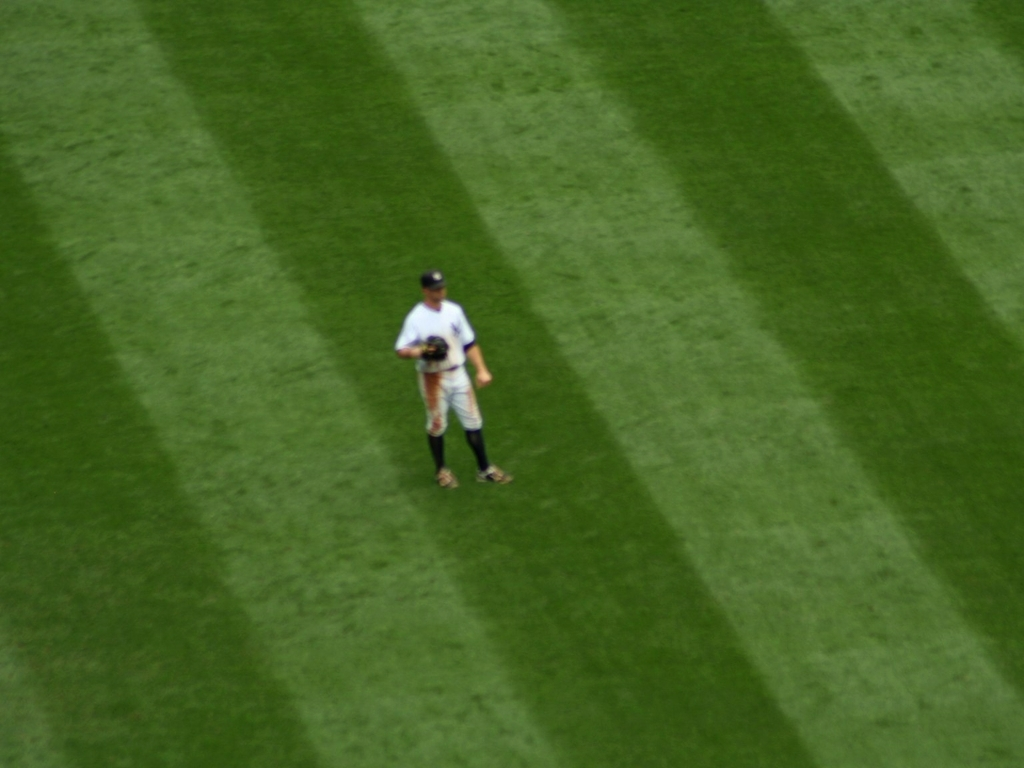Could the time of day influence the appearance of this image, and if so, how? Absolutely, the time of day can significantly affect the lighting conditions, which in turn influence how we perceive images. In this case, long shadows suggest that the photo was taken either in the early morning or late afternoon when the sun is low in the sky. This angle of the sun creates a stark contrast between light and shadow, providing a dramatic effect but also potentially washing out finer details. 